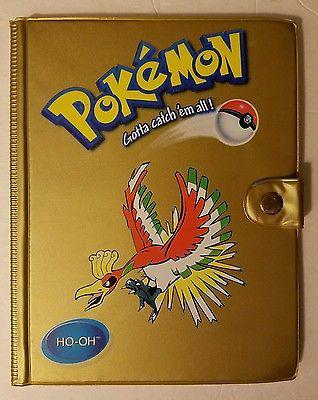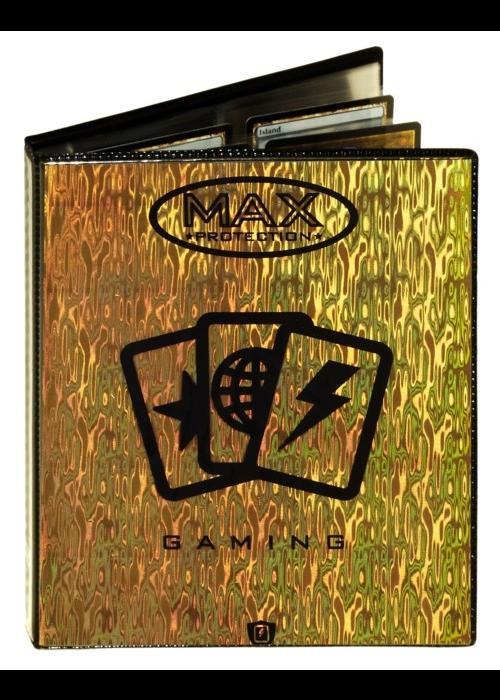The first image is the image on the left, the second image is the image on the right. Given the left and right images, does the statement "The image on the right is of a gold binder." hold true? Answer yes or no. Yes. 